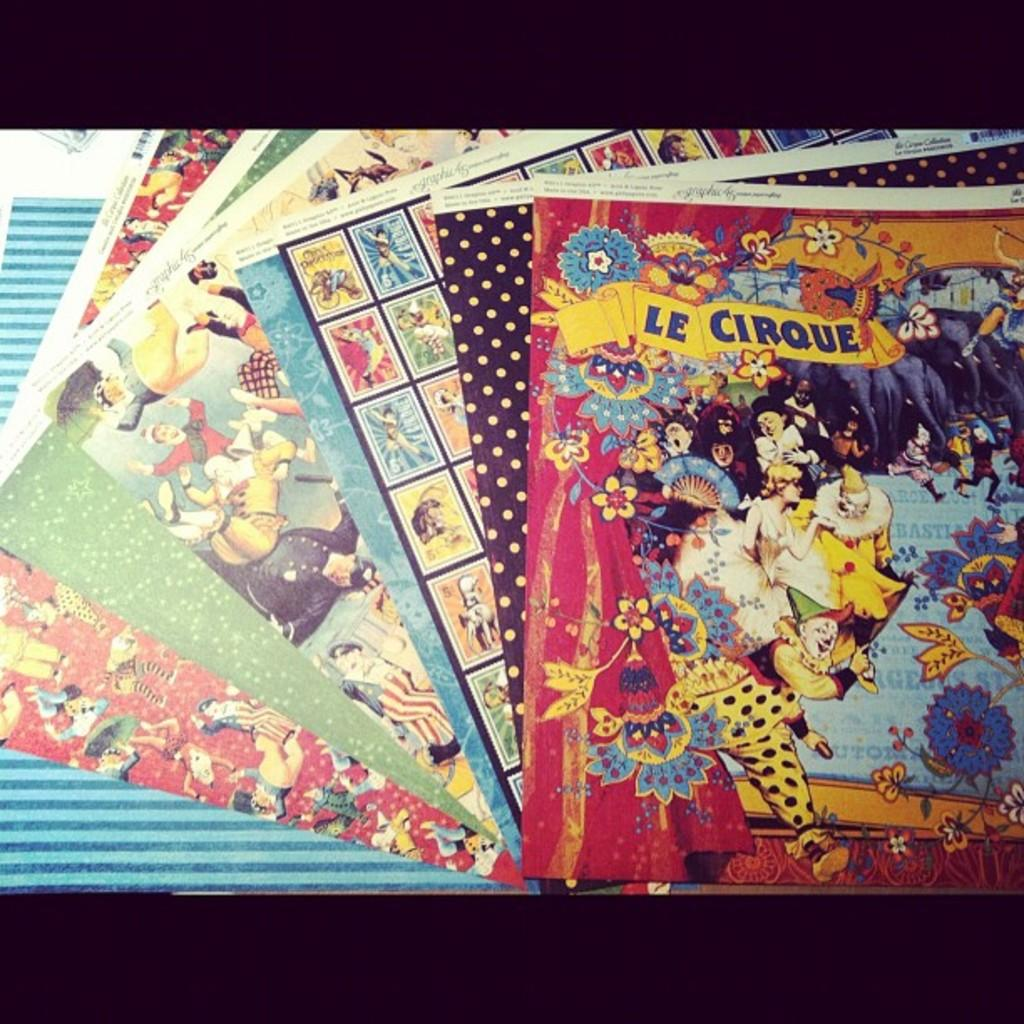<image>
Create a compact narrative representing the image presented. a pile of magazines where one of them says 'le cirque' on it 